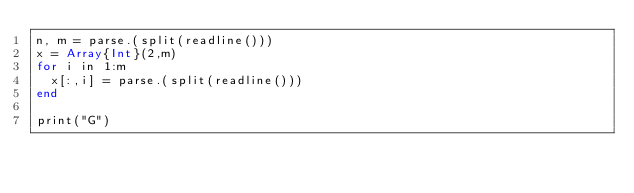<code> <loc_0><loc_0><loc_500><loc_500><_Julia_>n, m = parse.(split(readline()))
x = Array{Int}(2,m)
for i in 1:m
  x[:,i] = parse.(split(readline()))
end

print("G")</code> 